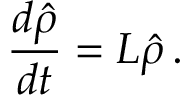Convert formula to latex. <formula><loc_0><loc_0><loc_500><loc_500>\frac { d \hat { \rho } } { d t } = L \hat { \rho } \, .</formula> 